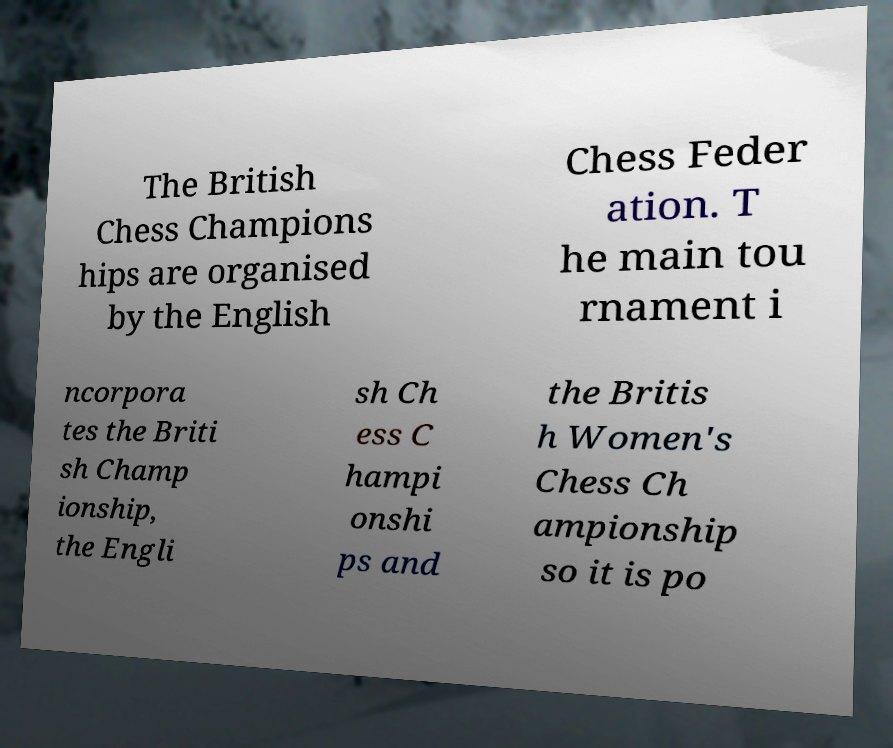I need the written content from this picture converted into text. Can you do that? The British Chess Champions hips are organised by the English Chess Feder ation. T he main tou rnament i ncorpora tes the Briti sh Champ ionship, the Engli sh Ch ess C hampi onshi ps and the Britis h Women's Chess Ch ampionship so it is po 